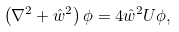Convert formula to latex. <formula><loc_0><loc_0><loc_500><loc_500>\left ( \nabla ^ { 2 } + { \hat { w } } ^ { 2 } \right ) \phi = 4 { \hat { w } } ^ { 2 } U \phi ,</formula> 